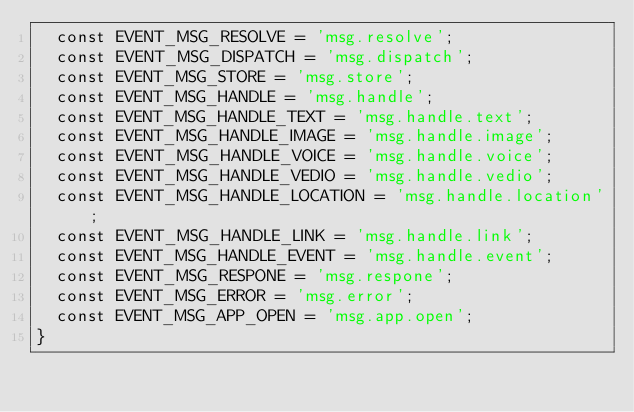Convert code to text. <code><loc_0><loc_0><loc_500><loc_500><_PHP_>	const EVENT_MSG_RESOLVE = 'msg.resolve';
	const EVENT_MSG_DISPATCH = 'msg.dispatch';
	const EVENT_MSG_STORE = 'msg.store';
	const EVENT_MSG_HANDLE = 'msg.handle';
	const EVENT_MSG_HANDLE_TEXT = 'msg.handle.text';
	const EVENT_MSG_HANDLE_IMAGE = 'msg.handle.image';
	const EVENT_MSG_HANDLE_VOICE = 'msg.handle.voice';
	const EVENT_MSG_HANDLE_VEDIO = 'msg.handle.vedio';
	const EVENT_MSG_HANDLE_LOCATION = 'msg.handle.location';
	const EVENT_MSG_HANDLE_LINK = 'msg.handle.link';
	const EVENT_MSG_HANDLE_EVENT = 'msg.handle.event';
	const EVENT_MSG_RESPONE = 'msg.respone';
	const EVENT_MSG_ERROR = 'msg.error';
	const EVENT_MSG_APP_OPEN = 'msg.app.open';
}</code> 